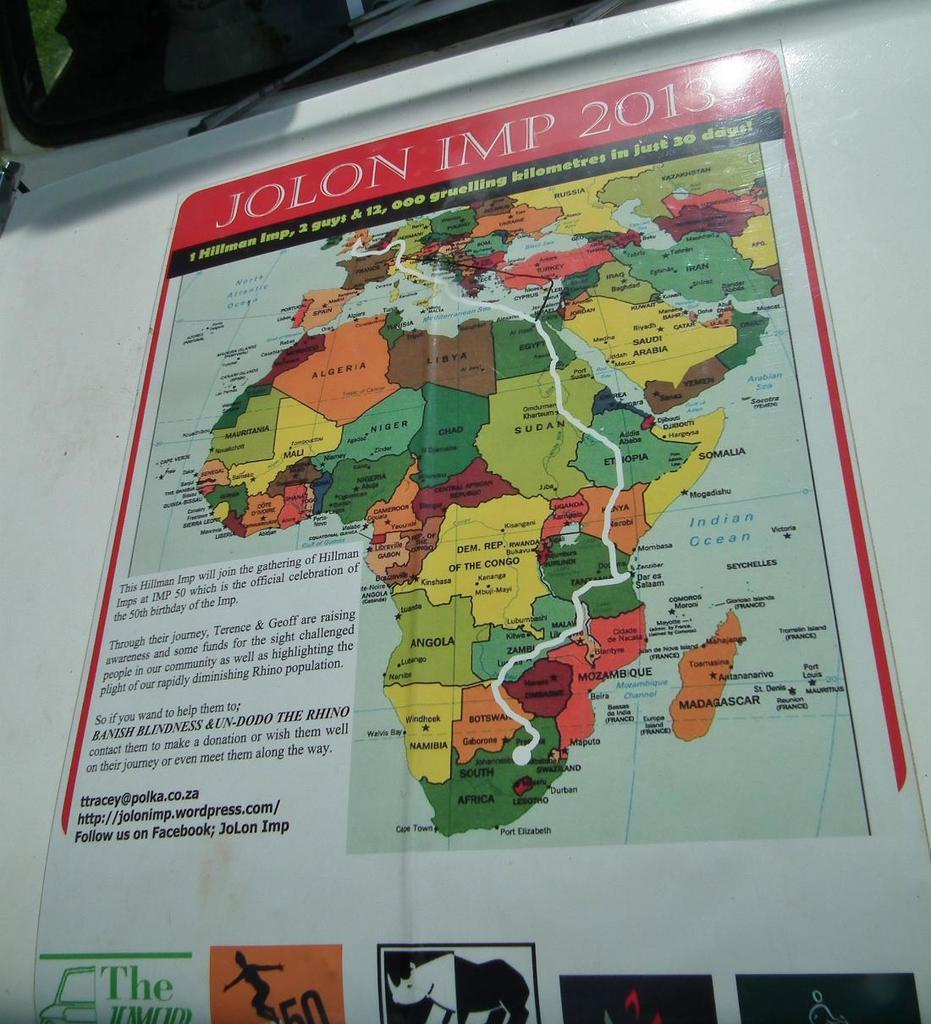<image>
Give a short and clear explanation of the subsequent image. A colored map of Africa with JOLON IMP 2013 in red at the top 